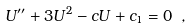<formula> <loc_0><loc_0><loc_500><loc_500>U ^ { \prime \prime } + 3 U ^ { 2 } - c U + c _ { 1 } = 0 \ ,</formula> 